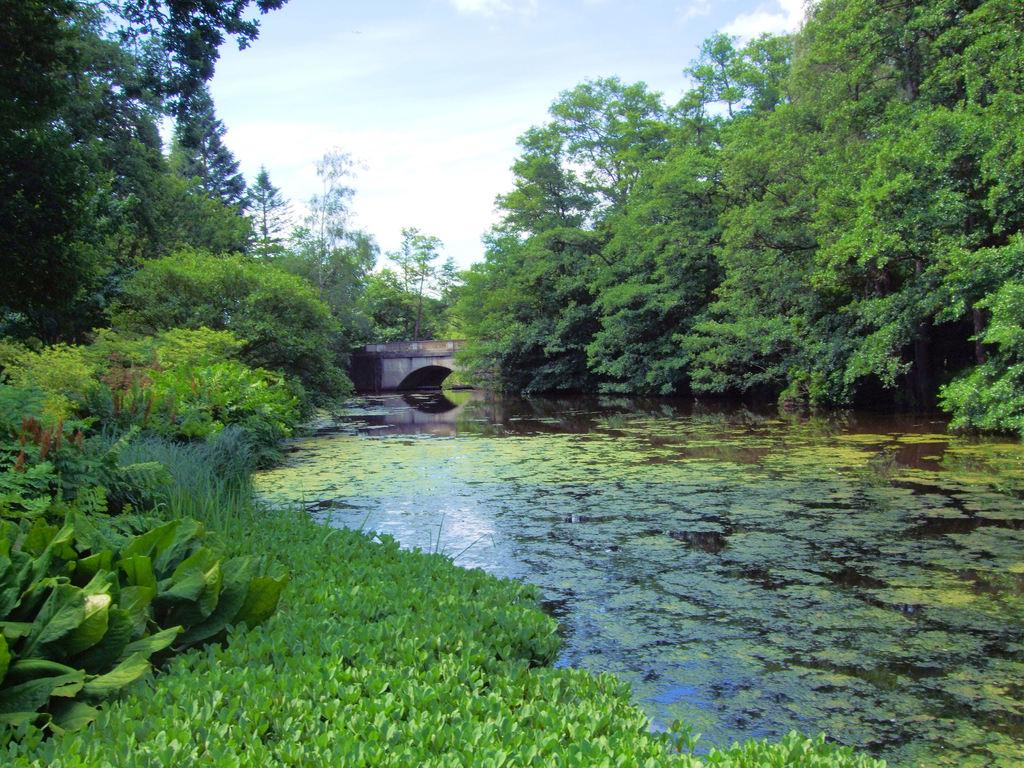What type of vegetation is present in the image? There are many trees and plants in the image. What is the water like in the image? The water has algae in it. What structure can be seen in the image? There is a bridge in the image. What is visible at the top of the image? The sky is visible at the top of the image. What type of celery is being used as a decoration on the bridge in the image? There is no celery present in the image, and the bridge is not being decorated with any vegetables. Where did the people go on vacation in the image? There are no people or indication of a vacation in the image. 